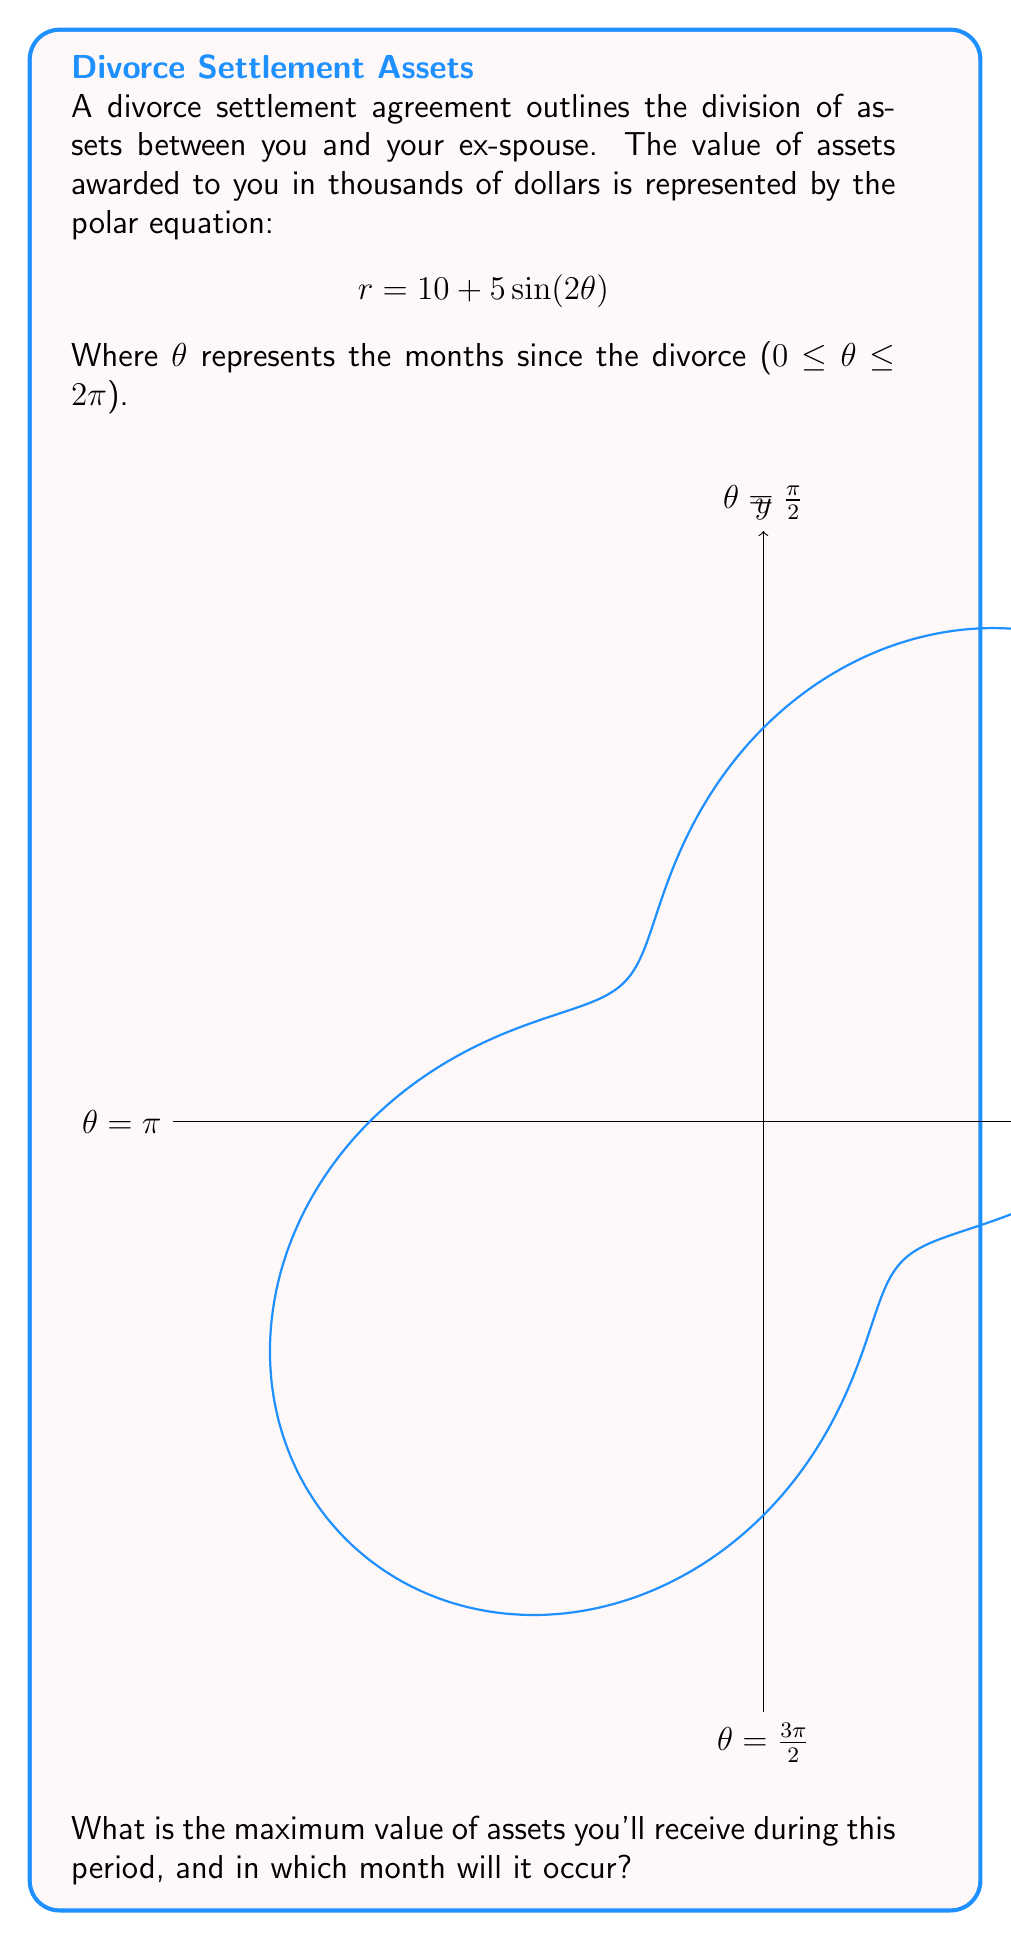What is the answer to this math problem? To find the maximum value of assets and when it occurs, we need to follow these steps:

1) The maximum value will occur when $\sin(2\theta)$ is at its maximum, which is 1.

2) When $\sin(2\theta) = 1$, the equation becomes:
   $$r_{max} = 10 + 5(1) = 15$$

3) This means the maximum value of assets is $15,000.

4) To find when this occurs, we need to solve:
   $$\sin(2\theta) = 1$$

5) This occurs when $2\theta = \frac{\pi}{2}$ (or odd multiples of $\frac{\pi}{2}$)

6) Solving for $\theta$:
   $$\theta = \frac{\pi}{4}$$ (considering only the first occurrence in the given range)

7) To convert this to months, we use the proportion:
   $$\frac{2\pi}{12} = \frac{\frac{\pi}{4}}{x}$$

8) Solving for x:
   $$x = \frac{12 \cdot \frac{\pi}{4}}{2\pi} = \frac{3}{2} = 1.5$$

Therefore, the maximum occurs 1.5 months after the divorce.
Answer: $15,000 at 1.5 months 